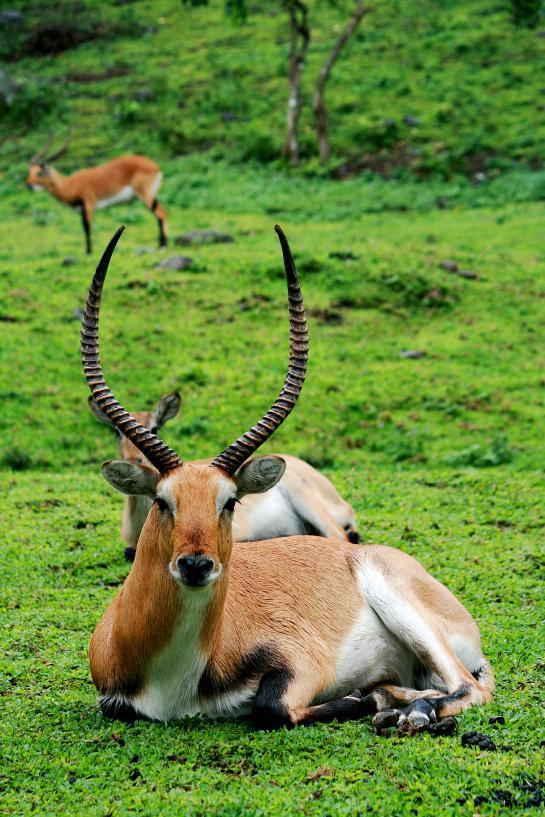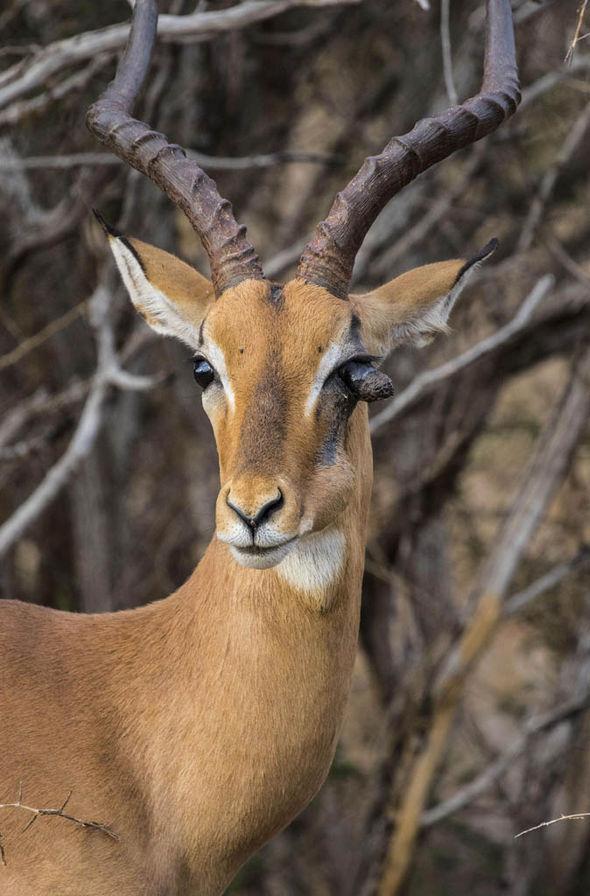The first image is the image on the left, the second image is the image on the right. Assess this claim about the two images: "You can see a second animal further off in the background.". Correct or not? Answer yes or no. Yes. 